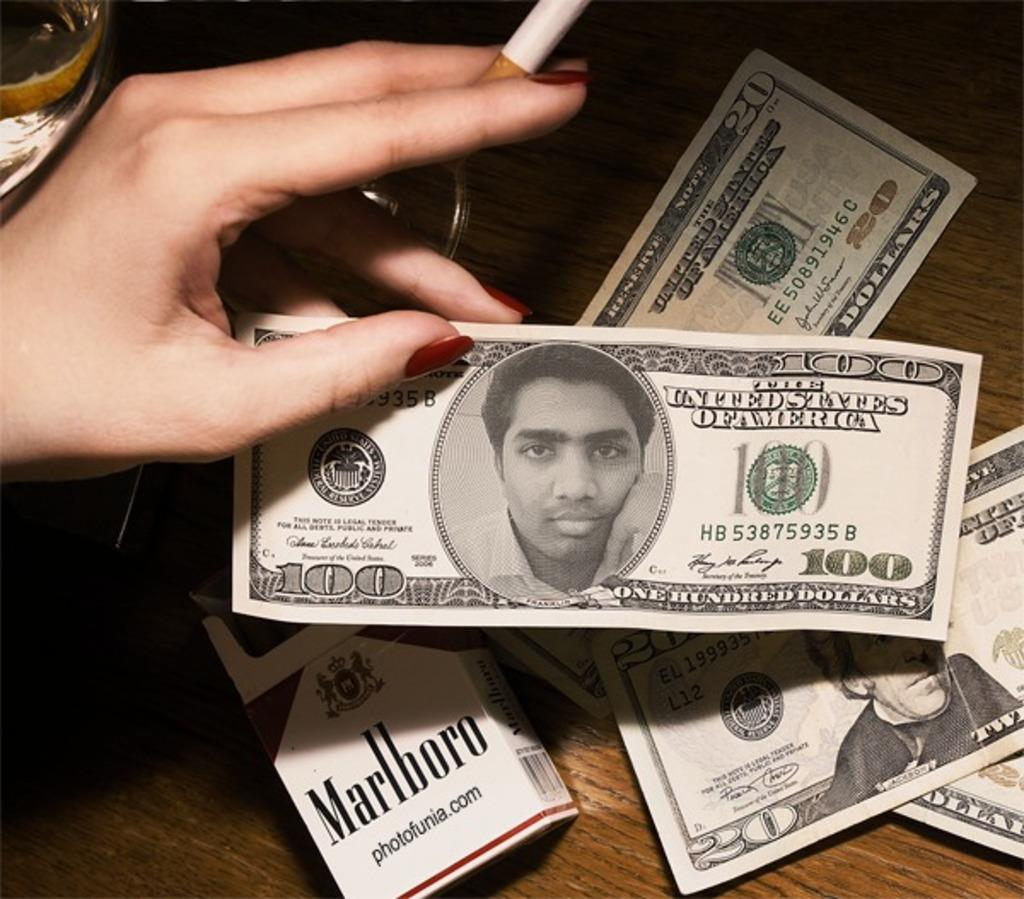<image>
Summarize the visual content of the image. A 100 dollar bill from the United States of America with the wrong picture on it. 